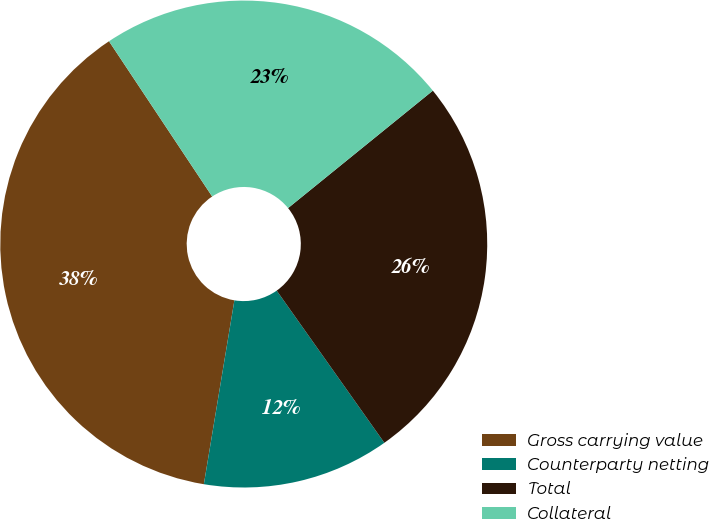Convert chart. <chart><loc_0><loc_0><loc_500><loc_500><pie_chart><fcel>Gross carrying value<fcel>Counterparty netting<fcel>Total<fcel>Collateral<nl><fcel>38.05%<fcel>12.42%<fcel>26.05%<fcel>23.49%<nl></chart> 